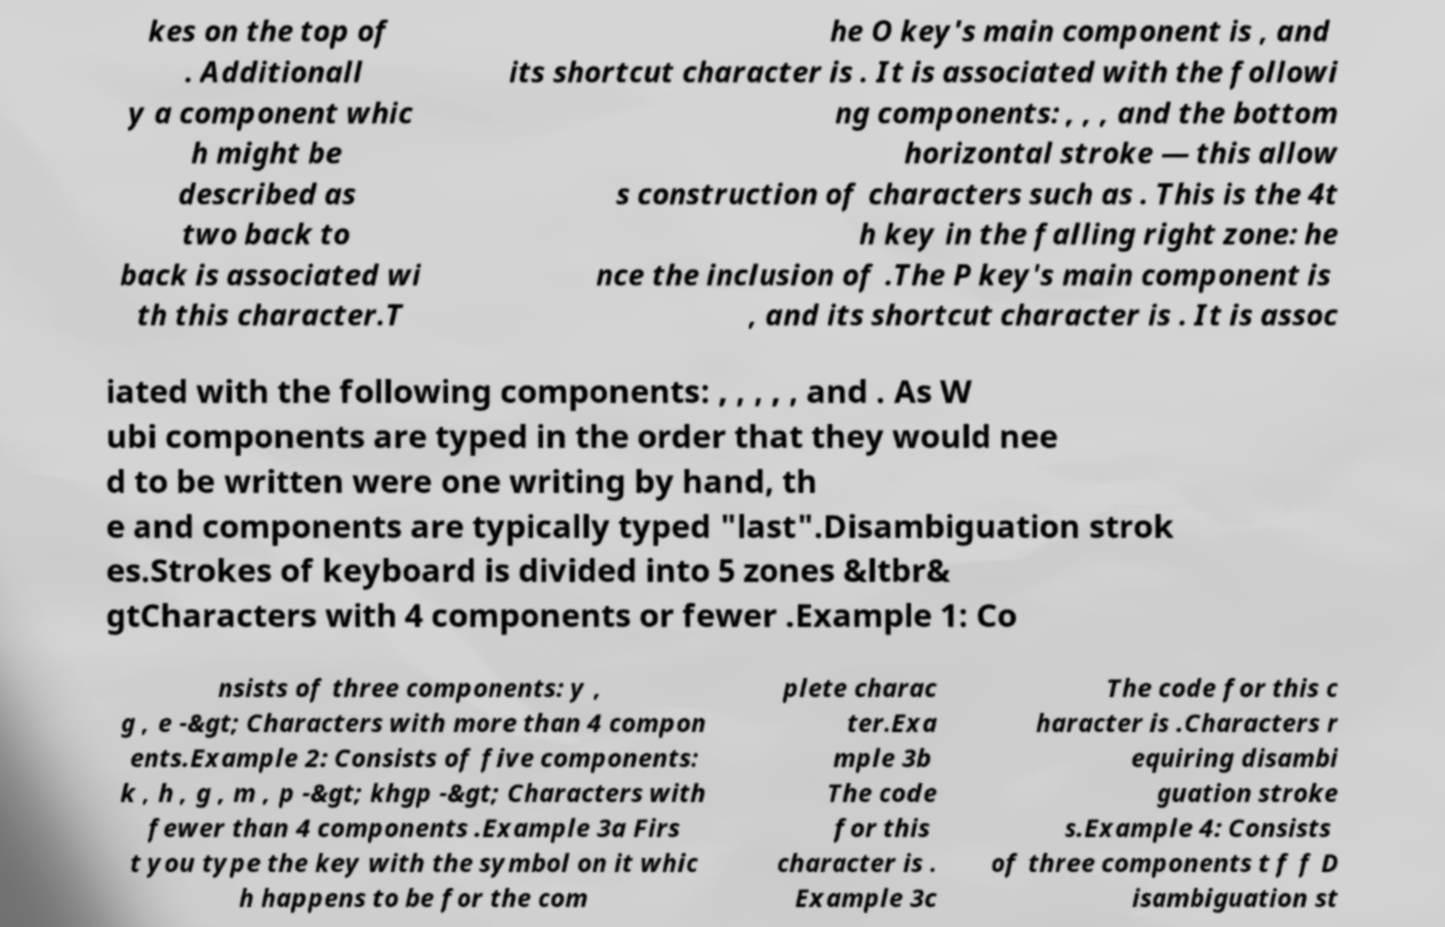I need the written content from this picture converted into text. Can you do that? kes on the top of . Additionall y a component whic h might be described as two back to back is associated wi th this character.T he O key's main component is , and its shortcut character is . It is associated with the followi ng components: , , , and the bottom horizontal stroke — this allow s construction of characters such as . This is the 4t h key in the falling right zone: he nce the inclusion of .The P key's main component is , and its shortcut character is . It is assoc iated with the following components: , , , , , and . As W ubi components are typed in the order that they would nee d to be written were one writing by hand, th e and components are typically typed "last".Disambiguation strok es.Strokes of keyboard is divided into 5 zones &ltbr& gtCharacters with 4 components or fewer .Example 1: Co nsists of three components: y , g , e -&gt; Characters with more than 4 compon ents.Example 2: Consists of five components: k , h , g , m , p -&gt; khgp -&gt; Characters with fewer than 4 components .Example 3a Firs t you type the key with the symbol on it whic h happens to be for the com plete charac ter.Exa mple 3b The code for this character is . Example 3c The code for this c haracter is .Characters r equiring disambi guation stroke s.Example 4: Consists of three components t f f D isambiguation st 